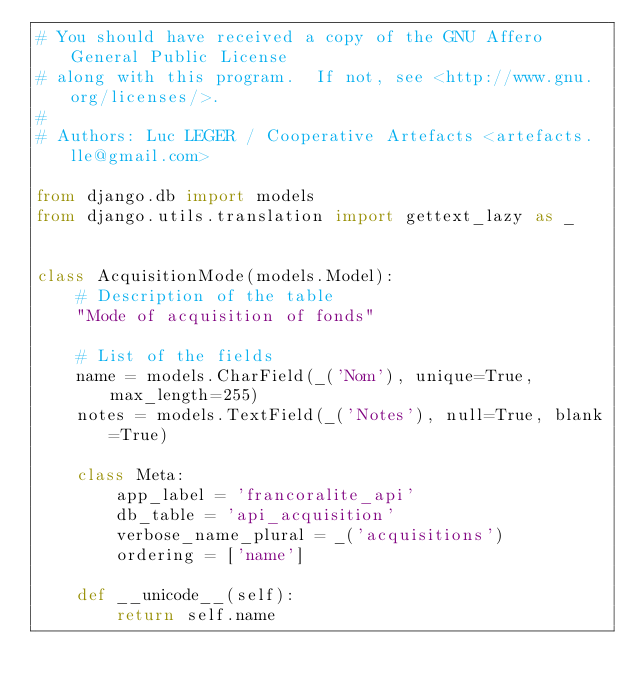Convert code to text. <code><loc_0><loc_0><loc_500><loc_500><_Python_># You should have received a copy of the GNU Affero General Public License
# along with this program.  If not, see <http://www.gnu.org/licenses/>.
#
# Authors: Luc LEGER / Cooperative Artefacts <artefacts.lle@gmail.com>

from django.db import models
from django.utils.translation import gettext_lazy as _


class AcquisitionMode(models.Model):
    # Description of the table
    "Mode of acquisition of fonds"

    # List of the fields
    name = models.CharField(_('Nom'), unique=True, max_length=255)
    notes = models.TextField(_('Notes'), null=True, blank=True)

    class Meta:
        app_label = 'francoralite_api'
        db_table = 'api_acquisition'
        verbose_name_plural = _('acquisitions')
        ordering = ['name']

    def __unicode__(self):
        return self.name
</code> 